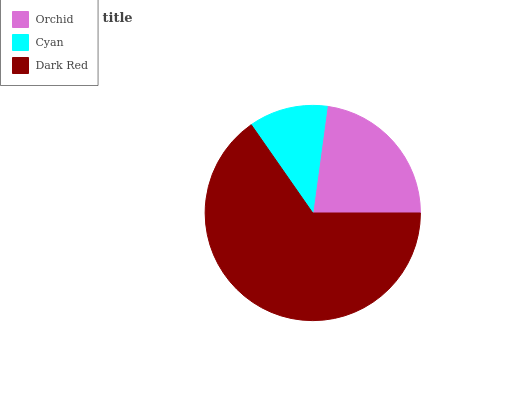Is Cyan the minimum?
Answer yes or no. Yes. Is Dark Red the maximum?
Answer yes or no. Yes. Is Dark Red the minimum?
Answer yes or no. No. Is Cyan the maximum?
Answer yes or no. No. Is Dark Red greater than Cyan?
Answer yes or no. Yes. Is Cyan less than Dark Red?
Answer yes or no. Yes. Is Cyan greater than Dark Red?
Answer yes or no. No. Is Dark Red less than Cyan?
Answer yes or no. No. Is Orchid the high median?
Answer yes or no. Yes. Is Orchid the low median?
Answer yes or no. Yes. Is Dark Red the high median?
Answer yes or no. No. Is Cyan the low median?
Answer yes or no. No. 